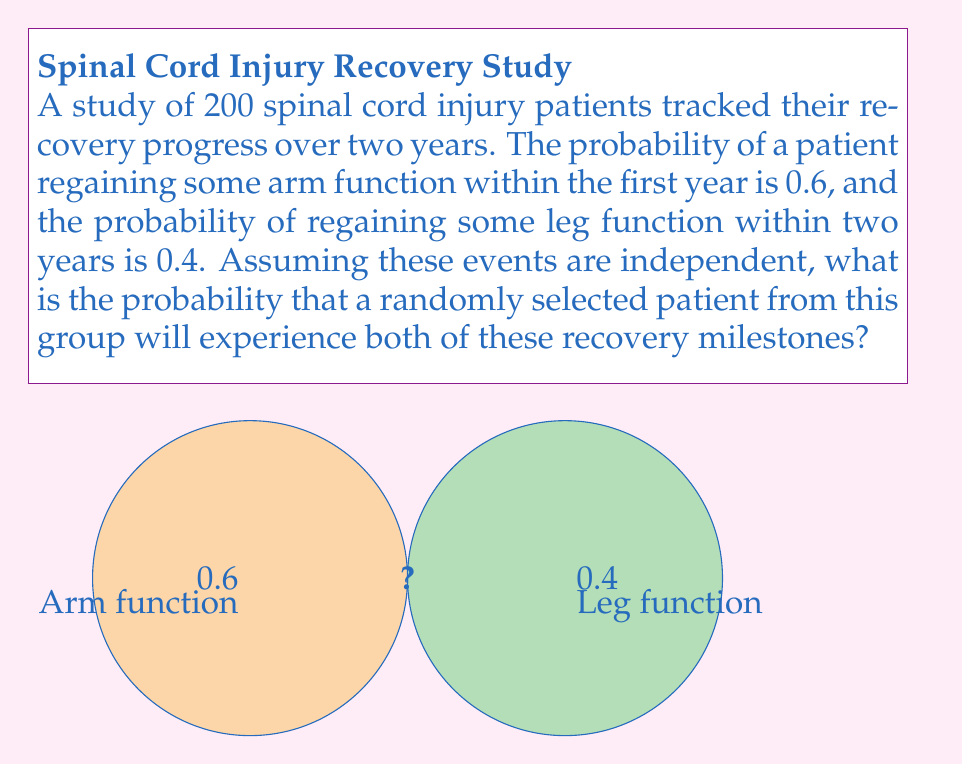Can you answer this question? To solve this problem, we need to use the concept of independent events in probability theory. When two events are independent, the probability of both events occurring is the product of their individual probabilities.

Let's define our events:
A: Patient regains some arm function within the first year
B: Patient regains some leg function within two years

Given:
P(A) = 0.6
P(B) = 0.4

We want to find P(A and B), which is the probability of both events occurring.

For independent events:

$$ P(A \text{ and } B) = P(A) \times P(B) $$

Substituting the given probabilities:

$$ P(A \text{ and } B) = 0.6 \times 0.4 $$

$$ P(A \text{ and } B) = 0.24 $$

Therefore, the probability that a randomly selected patient will experience both recovery milestones is 0.24 or 24%.
Answer: 0.24 